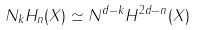<formula> <loc_0><loc_0><loc_500><loc_500>N _ { k } H _ { n } ( X ) \simeq N ^ { d - k } H ^ { 2 d - n } ( X )</formula> 